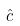<formula> <loc_0><loc_0><loc_500><loc_500>\hat { c }</formula> 